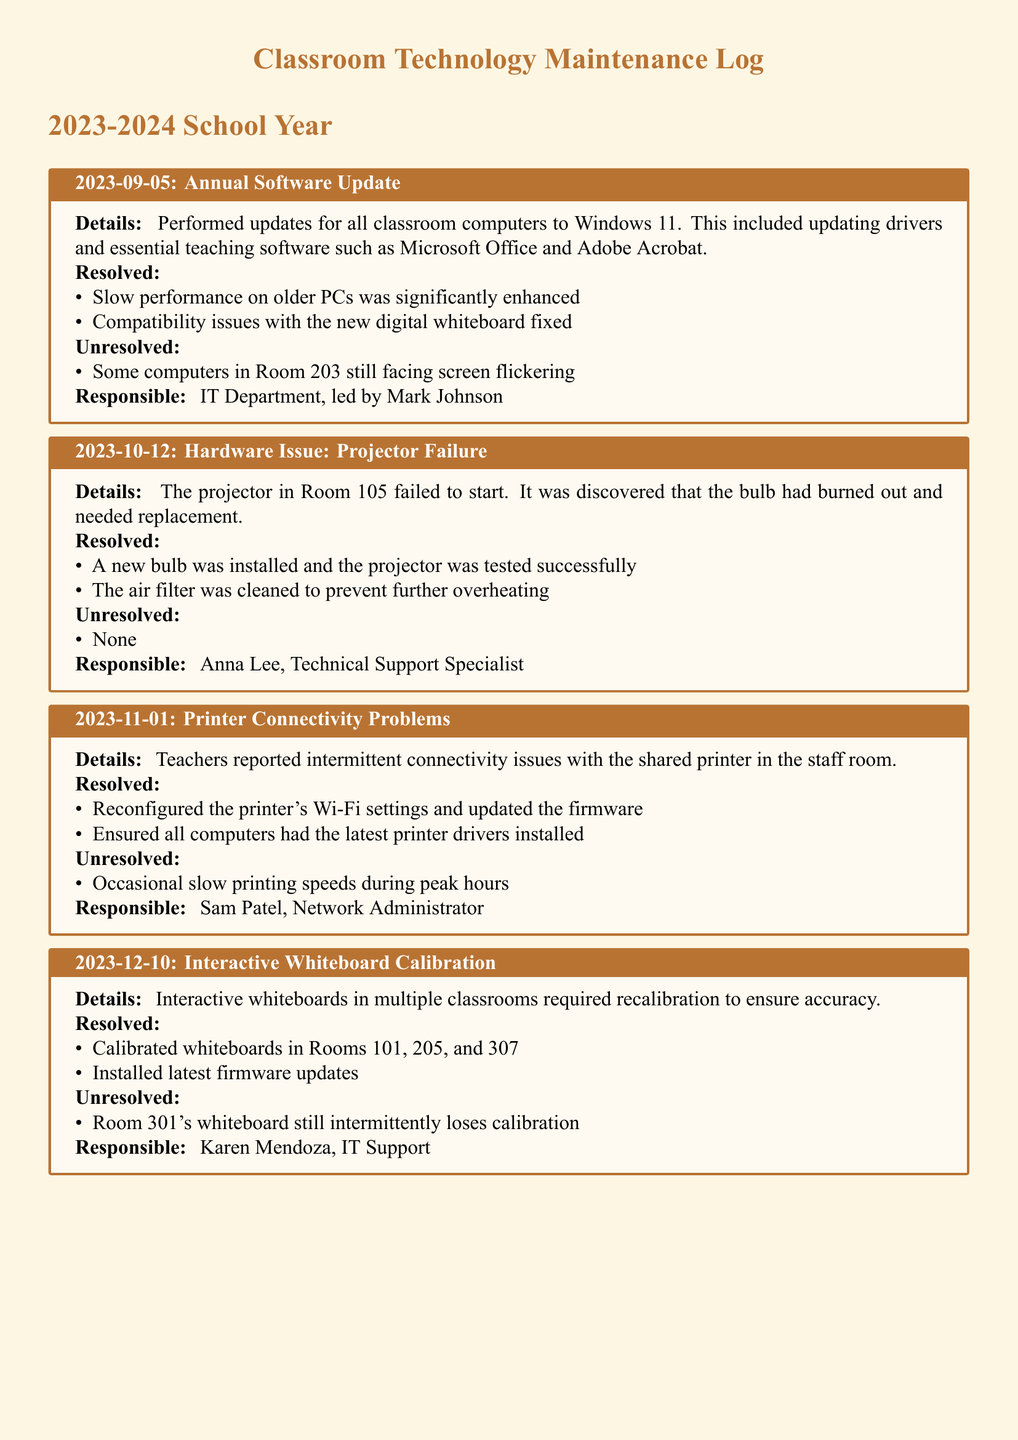What date was the annual software update performed? The annual software update was performed on September 5, 2023.
Answer: September 5, 2023 Who is responsible for the projector failure resolution? The resolution for the projector failure was handled by Anna Lee, the Technical Support Specialist.
Answer: Anna Lee What issue was identified with the interactive whiteboard in Room 301? The interactive whiteboard in Room 301 was reported to intermittently lose calibration.
Answer: Intermittently loses calibration How many classrooms had their whiteboards calibrated? Whiteboards in three classrooms (Rooms 101, 205, and 307) were calibrated.
Answer: Three What was the problem with the online gradebook software? The online gradebook software wouldn't save new entries.
Answer: Wouldn't save new entries What maintenance action was taken regarding the shared printer? The printer's Wi-Fi settings were reconfigured and its firmware was updated.
Answer: Reconfigured Wi-Fi settings and updated firmware What repair did the projector in Room 105 require? The projector in Room 105 required a new bulb replacement.
Answer: New bulb replacement Which room's whiteboard still had an unresolved issue? Room 301's whiteboard still had an unresolved calibration issue.
Answer: Room 301 